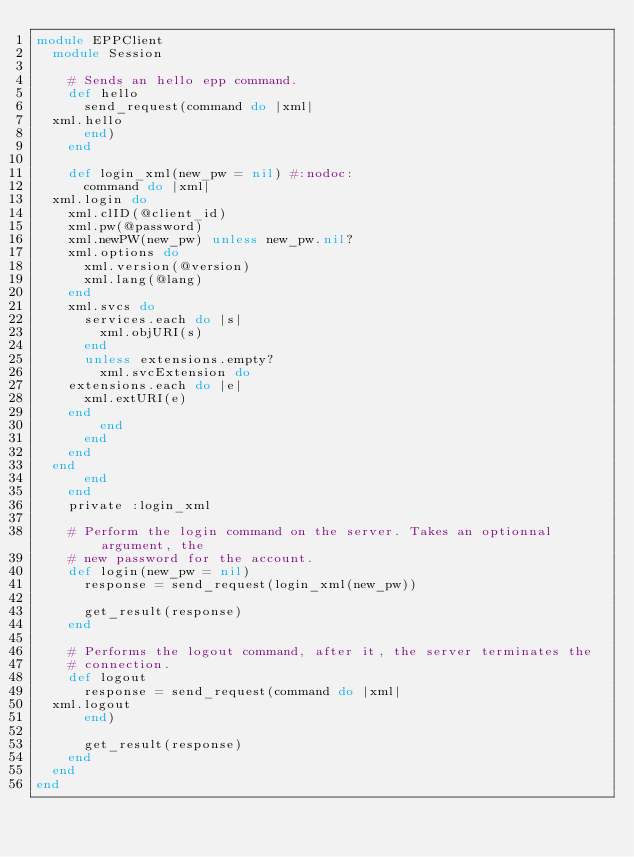<code> <loc_0><loc_0><loc_500><loc_500><_Ruby_>module EPPClient
  module Session

    # Sends an hello epp command.
    def hello
      send_request(command do |xml|
	xml.hello
      end)
    end

    def login_xml(new_pw = nil) #:nodoc:
      command do |xml|
	xml.login do
	  xml.clID(@client_id)
	  xml.pw(@password)
	  xml.newPW(new_pw) unless new_pw.nil?
	  xml.options do
	    xml.version(@version)
	    xml.lang(@lang)
	  end
	  xml.svcs do
	    services.each do |s|
	      xml.objURI(s)
	    end
	    unless extensions.empty?
	      xml.svcExtension do
		extensions.each do |e|
		  xml.extURI(e)
		end
	      end
	    end
	  end
	end
      end
    end
    private :login_xml

    # Perform the login command on the server. Takes an optionnal argument, the
    # new password for the account.
    def login(new_pw = nil)
      response = send_request(login_xml(new_pw))

      get_result(response)
    end

    # Performs the logout command, after it, the server terminates the
    # connection.
    def logout
      response = send_request(command do |xml|
	xml.logout
      end)

      get_result(response)
    end
  end
end
</code> 